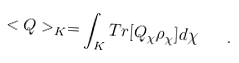Convert formula to latex. <formula><loc_0><loc_0><loc_500><loc_500>< Q > _ { K } = \int _ { K } T r [ Q _ { \chi } \rho _ { \chi } ] d \chi \quad .</formula> 